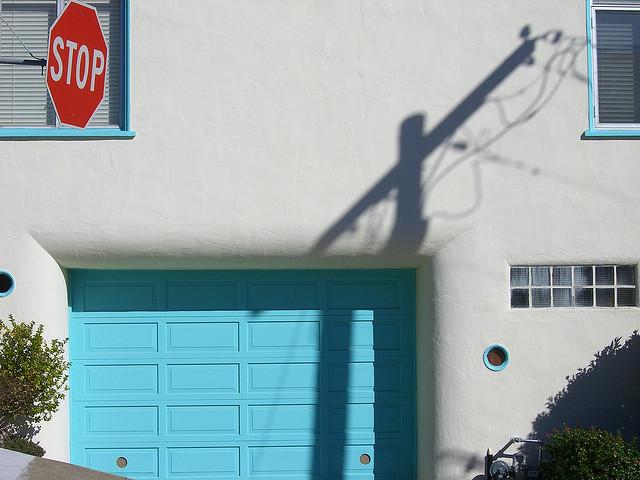What does the sign say?
Keep it brief. Stop. What color is the door?
Concise answer only. Blue. From what is the shadow casted?
Quick response, please. Telephone pole. Is there graffiti on this stop sign?
Write a very short answer. No. Is this a skateboarding event?
Answer briefly. No. What does the red sign say?
Quick response, please. Stop. 